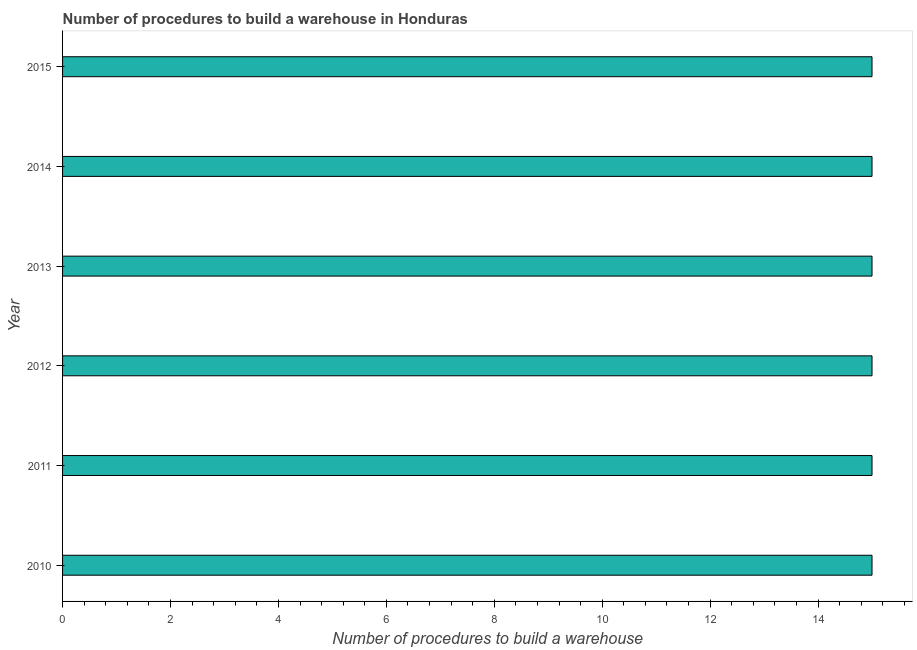Does the graph contain any zero values?
Give a very brief answer. No. What is the title of the graph?
Provide a succinct answer. Number of procedures to build a warehouse in Honduras. What is the label or title of the X-axis?
Ensure brevity in your answer.  Number of procedures to build a warehouse. What is the number of procedures to build a warehouse in 2012?
Provide a short and direct response. 15. Across all years, what is the maximum number of procedures to build a warehouse?
Your response must be concise. 15. Across all years, what is the minimum number of procedures to build a warehouse?
Provide a short and direct response. 15. In which year was the number of procedures to build a warehouse maximum?
Provide a succinct answer. 2010. What is the median number of procedures to build a warehouse?
Keep it short and to the point. 15. Do a majority of the years between 2015 and 2010 (inclusive) have number of procedures to build a warehouse greater than 2.8 ?
Your answer should be compact. Yes. What is the difference between the highest and the second highest number of procedures to build a warehouse?
Provide a short and direct response. 0. In how many years, is the number of procedures to build a warehouse greater than the average number of procedures to build a warehouse taken over all years?
Give a very brief answer. 0. How many bars are there?
Offer a very short reply. 6. How many years are there in the graph?
Your answer should be compact. 6. What is the difference between two consecutive major ticks on the X-axis?
Give a very brief answer. 2. What is the Number of procedures to build a warehouse in 2011?
Make the answer very short. 15. What is the Number of procedures to build a warehouse of 2012?
Your answer should be compact. 15. What is the Number of procedures to build a warehouse in 2013?
Your answer should be compact. 15. What is the Number of procedures to build a warehouse of 2014?
Offer a terse response. 15. What is the difference between the Number of procedures to build a warehouse in 2010 and 2012?
Provide a short and direct response. 0. What is the difference between the Number of procedures to build a warehouse in 2010 and 2014?
Provide a short and direct response. 0. What is the difference between the Number of procedures to build a warehouse in 2010 and 2015?
Your response must be concise. 0. What is the difference between the Number of procedures to build a warehouse in 2011 and 2012?
Your response must be concise. 0. What is the difference between the Number of procedures to build a warehouse in 2011 and 2014?
Make the answer very short. 0. What is the difference between the Number of procedures to build a warehouse in 2011 and 2015?
Ensure brevity in your answer.  0. What is the difference between the Number of procedures to build a warehouse in 2012 and 2015?
Make the answer very short. 0. What is the ratio of the Number of procedures to build a warehouse in 2010 to that in 2011?
Make the answer very short. 1. What is the ratio of the Number of procedures to build a warehouse in 2010 to that in 2012?
Offer a terse response. 1. What is the ratio of the Number of procedures to build a warehouse in 2010 to that in 2013?
Ensure brevity in your answer.  1. What is the ratio of the Number of procedures to build a warehouse in 2010 to that in 2014?
Offer a very short reply. 1. What is the ratio of the Number of procedures to build a warehouse in 2010 to that in 2015?
Keep it short and to the point. 1. What is the ratio of the Number of procedures to build a warehouse in 2011 to that in 2012?
Make the answer very short. 1. What is the ratio of the Number of procedures to build a warehouse in 2011 to that in 2013?
Make the answer very short. 1. What is the ratio of the Number of procedures to build a warehouse in 2011 to that in 2015?
Your answer should be compact. 1. What is the ratio of the Number of procedures to build a warehouse in 2012 to that in 2013?
Make the answer very short. 1. What is the ratio of the Number of procedures to build a warehouse in 2012 to that in 2014?
Your response must be concise. 1. What is the ratio of the Number of procedures to build a warehouse in 2012 to that in 2015?
Provide a succinct answer. 1. What is the ratio of the Number of procedures to build a warehouse in 2013 to that in 2014?
Ensure brevity in your answer.  1. What is the ratio of the Number of procedures to build a warehouse in 2013 to that in 2015?
Provide a succinct answer. 1. 